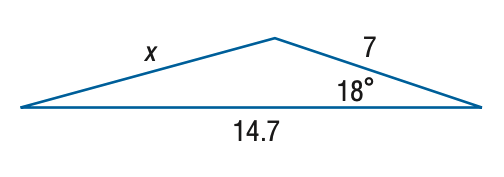Question: Find x. Round the side measure to the nearest tenth.
Choices:
A. 4.2
B. 8.3
C. 16.7
D. 69.4
Answer with the letter. Answer: B 